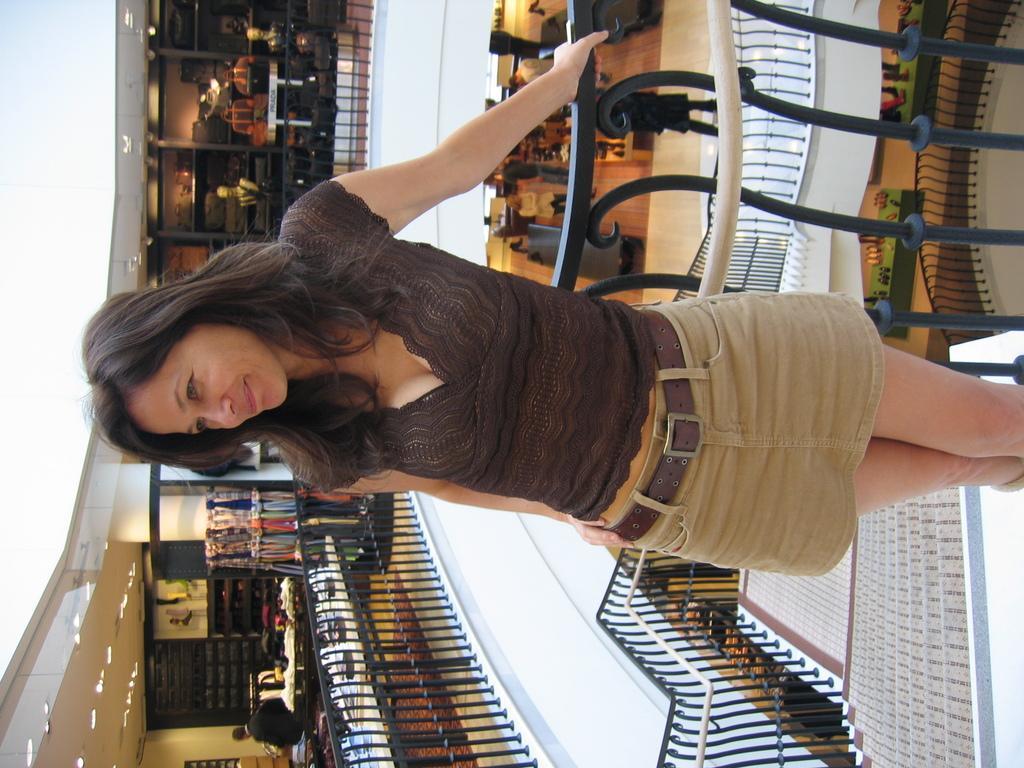How would you summarize this image in a sentence or two? In this image, we can see people wearing clothes. There are safety barriers in the middle of the image. They are clothes and bags on the left side of the image. There are lights in the bottom left of the image. 